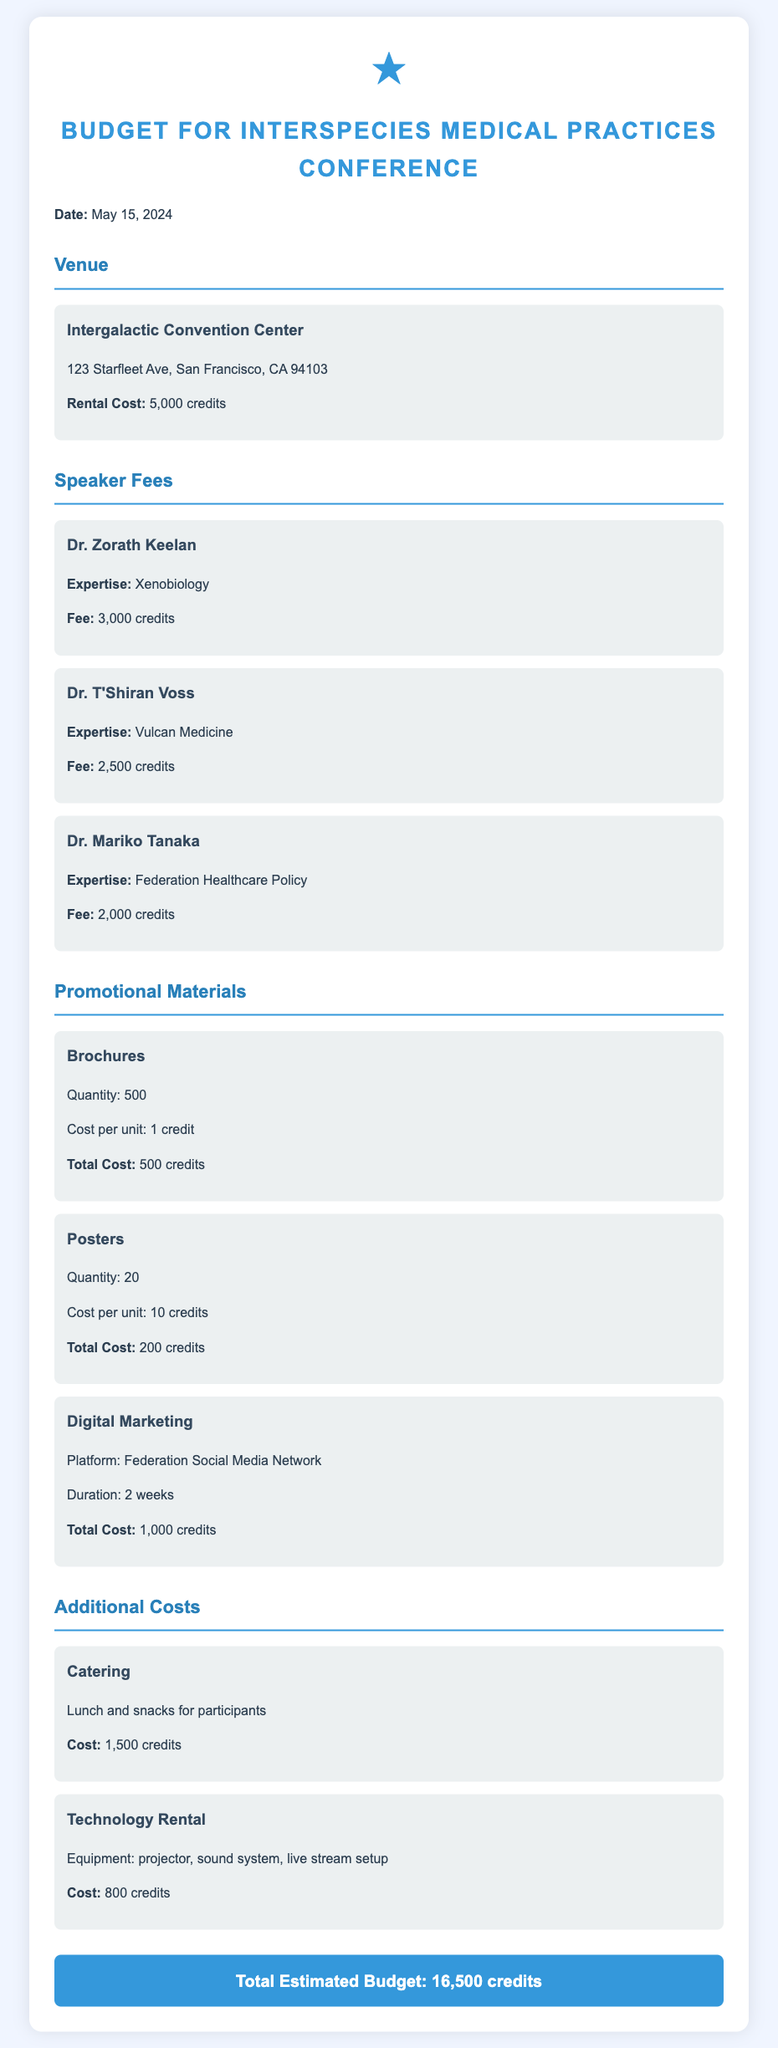What is the date of the conference? The document states that the conference is scheduled for May 15, 2024.
Answer: May 15, 2024 How much is the venue rental cost? The venue rental cost provided in the document is specified as 5,000 credits.
Answer: 5,000 credits Who is the speaker with expertise in Vulcan Medicine? The document lists Dr. T'Shiran Voss as the speaker specializing in Vulcan Medicine.
Answer: Dr. T'Shiran Voss What is the total cost for brochures? The document indicates that the total cost for brochures is 500 credits based on the quantity and cost per unit.
Answer: 500 credits What is the total estimated budget for the conference? The total estimated budget is the sum of all expenses outlined in the document, which is mentioned as 16,500 credits.
Answer: 16,500 credits What is the total fee for Dr. Zorath Keelan? The fee for Dr. Zorath Keelan is explicitly stated in the document as 3,000 credits.
Answer: 3,000 credits How many posters are planned for the conference? The document specifies that 20 posters are planned for the event.
Answer: 20 What additional cost involves a projector and sound system? The document refers to the Technology Rental as the additional cost that includes equipment like a projector and sound system.
Answer: Technology Rental What type of digital marketing platform will be used? The document notes that the digital marketing will be conducted on the Federation Social Media Network.
Answer: Federation Social Media Network 